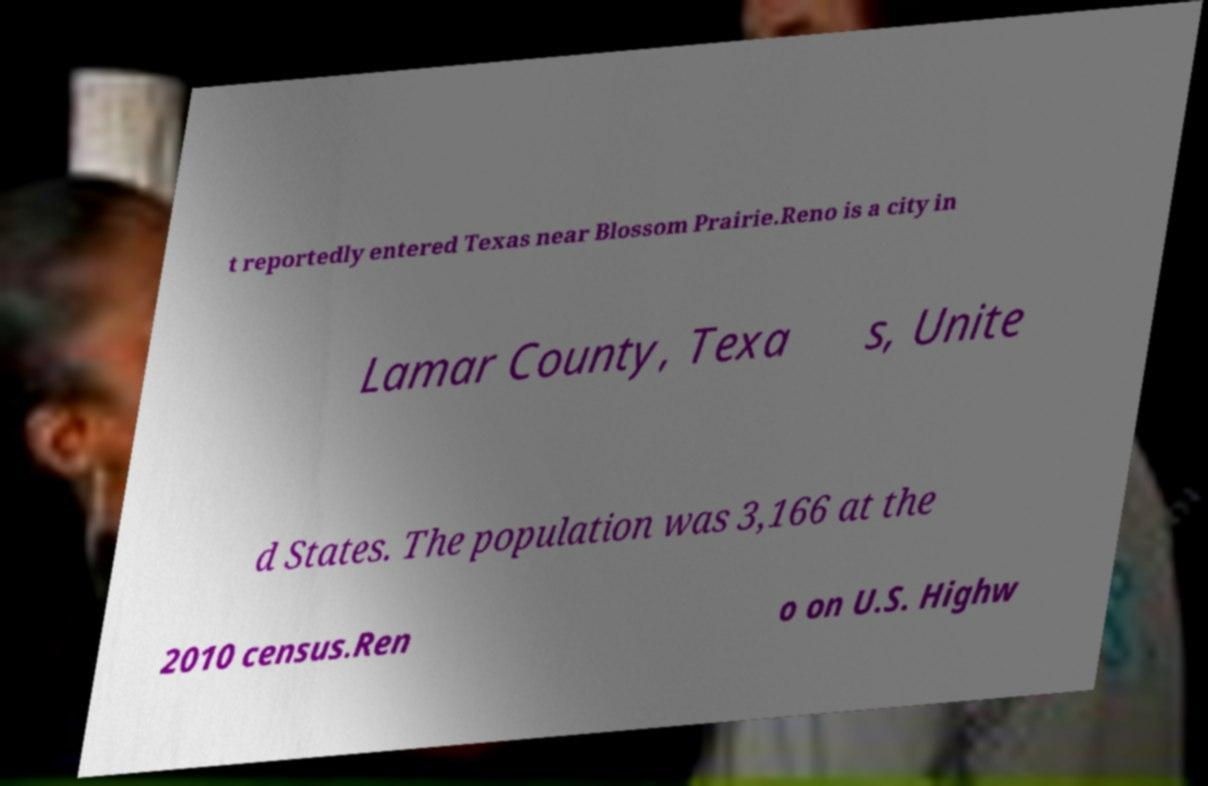Could you assist in decoding the text presented in this image and type it out clearly? t reportedly entered Texas near Blossom Prairie.Reno is a city in Lamar County, Texa s, Unite d States. The population was 3,166 at the 2010 census.Ren o on U.S. Highw 